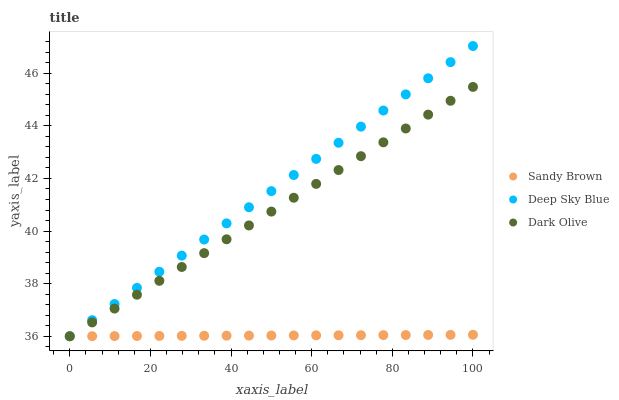Does Sandy Brown have the minimum area under the curve?
Answer yes or no. Yes. Does Deep Sky Blue have the maximum area under the curve?
Answer yes or no. Yes. Does Deep Sky Blue have the minimum area under the curve?
Answer yes or no. No. Does Sandy Brown have the maximum area under the curve?
Answer yes or no. No. Is Sandy Brown the smoothest?
Answer yes or no. Yes. Is Dark Olive the roughest?
Answer yes or no. Yes. Is Deep Sky Blue the smoothest?
Answer yes or no. No. Is Deep Sky Blue the roughest?
Answer yes or no. No. Does Dark Olive have the lowest value?
Answer yes or no. Yes. Does Deep Sky Blue have the highest value?
Answer yes or no. Yes. Does Sandy Brown have the highest value?
Answer yes or no. No. Does Deep Sky Blue intersect Dark Olive?
Answer yes or no. Yes. Is Deep Sky Blue less than Dark Olive?
Answer yes or no. No. Is Deep Sky Blue greater than Dark Olive?
Answer yes or no. No. 